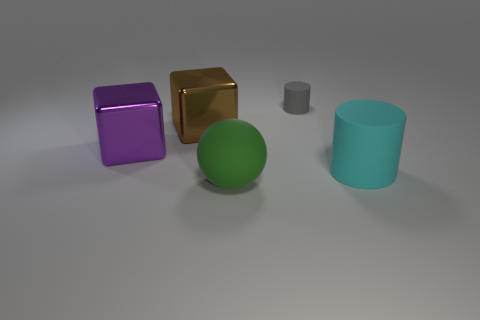Add 3 small blocks. How many objects exist? 8 Subtract all cubes. How many objects are left? 3 Add 1 purple objects. How many purple objects exist? 2 Subtract 0 brown cylinders. How many objects are left? 5 Subtract all large red cylinders. Subtract all gray rubber objects. How many objects are left? 4 Add 4 purple metal objects. How many purple metal objects are left? 5 